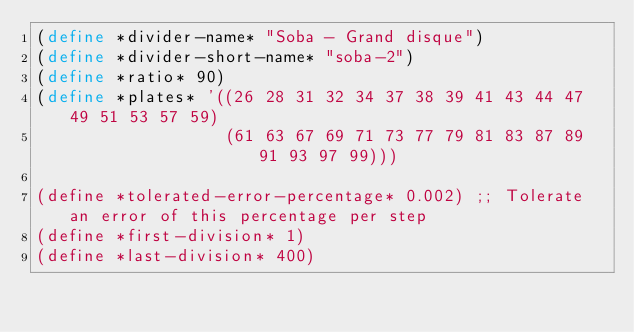Convert code to text. <code><loc_0><loc_0><loc_500><loc_500><_Scheme_>(define *divider-name* "Soba - Grand disque")
(define *divider-short-name* "soba-2")
(define *ratio* 90)    
(define *plates* '((26 28 31 32 34 37 38 39 41 43 44 47 49 51 53 57 59)
                   (61 63 67 69 71 73 77 79 81 83 87 89 91 93 97 99)))
		 	
(define *tolerated-error-percentage* 0.002) ;; Tolerate an error of this percentage per step
(define *first-division* 1)
(define *last-division* 400)
</code> 